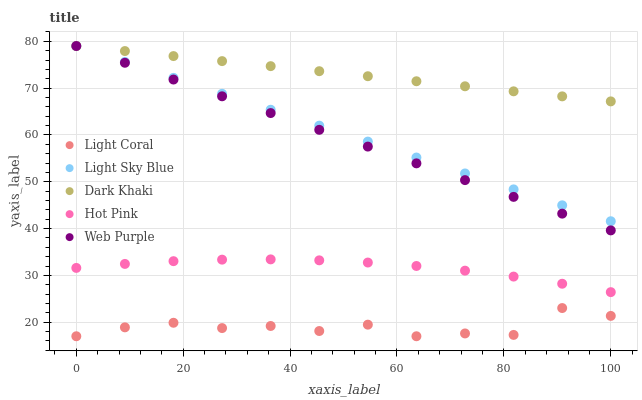Does Light Coral have the minimum area under the curve?
Answer yes or no. Yes. Does Dark Khaki have the maximum area under the curve?
Answer yes or no. Yes. Does Web Purple have the minimum area under the curve?
Answer yes or no. No. Does Web Purple have the maximum area under the curve?
Answer yes or no. No. Is Light Sky Blue the smoothest?
Answer yes or no. Yes. Is Light Coral the roughest?
Answer yes or no. Yes. Is Dark Khaki the smoothest?
Answer yes or no. No. Is Dark Khaki the roughest?
Answer yes or no. No. Does Light Coral have the lowest value?
Answer yes or no. Yes. Does Web Purple have the lowest value?
Answer yes or no. No. Does Light Sky Blue have the highest value?
Answer yes or no. Yes. Does Hot Pink have the highest value?
Answer yes or no. No. Is Hot Pink less than Dark Khaki?
Answer yes or no. Yes. Is Dark Khaki greater than Hot Pink?
Answer yes or no. Yes. Does Light Sky Blue intersect Web Purple?
Answer yes or no. Yes. Is Light Sky Blue less than Web Purple?
Answer yes or no. No. Is Light Sky Blue greater than Web Purple?
Answer yes or no. No. Does Hot Pink intersect Dark Khaki?
Answer yes or no. No. 